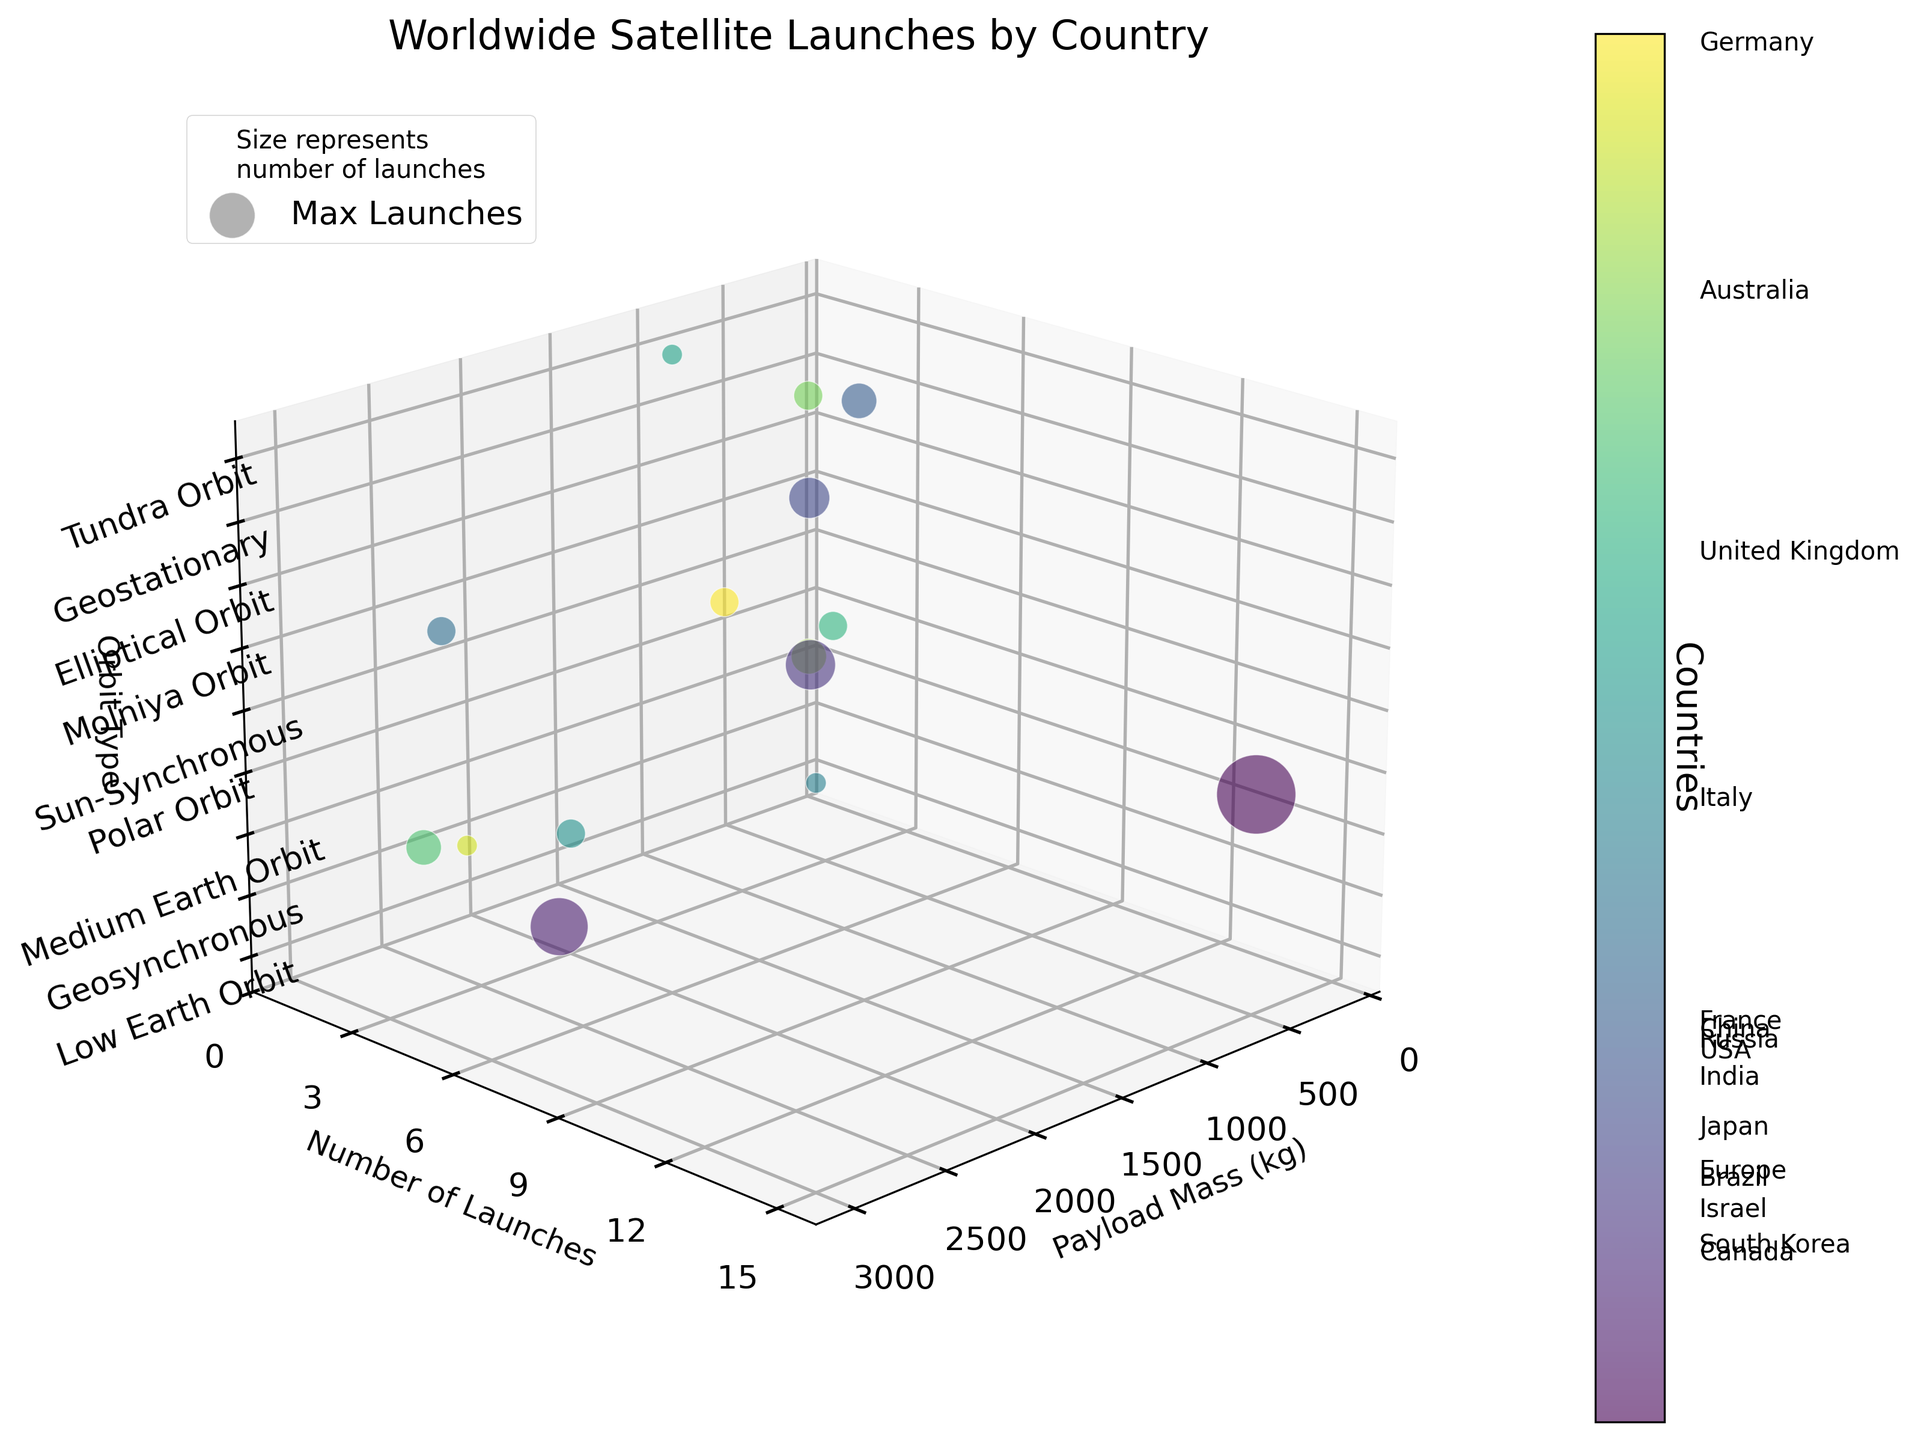How many different orbit types are represented in the figure? The z-axis of the figure represents different orbit types. By counting the unique labels on the z-axis, we see the distinct orbit types.
Answer: 8 Which country has the highest number of satellite launches? Look for the largest bubble on the z-axis labeled by orbit type and payload mass. The largest bubble corresponds to the country with the highest number of launches.
Answer: USA What is the payload mass range displayed on the x-axis? The x-axis denotes payload mass in kilograms. Checking the axis range, it spans from the smallest to the largest value indicated on the figure.
Answer: 0 to 3000 kg Compare the number of launches between Brazil and Japan. Which country has more? Locate Brazil and Japan on the z-axis and compare their corresponding sizes, indicating the number of launches.
Answer: Brazil What is the total payload mass launched by countries in Low Earth Orbit? Find all bubbles with the z-label 'Low Earth Orbit', sum their respective x-values (payload masses).
Answer: 1350 kg Which country has the smallest payload mass and what is its orbit type? Find the smallest x-axis value and its corresponding position to determine the country and its orbit type.
Answer: Israel, Elliptical Orbit What is the payload mass for France and which orbit type does it correspond to? Locate the France label in the color bar and trace its bubble to the x-axis (payload mass) and z-axis (orbit type).
Answer: 2800 kg, Geosynchronous Among countries with Geostationary orbits, which has the highest payload mass? Identify bubbles aligned with the 'Geostationary' z-label and compare their x-values (payload masses).
Answer: Australia How does the number of launches for Italy compare to that of South Korea? Check the bubbles corresponding to Italy and South Korea, comparing their sizes to see which country has more launches.
Answer: South Korea has more launches What is the average payload mass launched by the USA? The USA has one bubble with its payload mass provided on the x-axis. Since there is only one data point, the average is the same as the payload mass.
Answer: 500 kg 